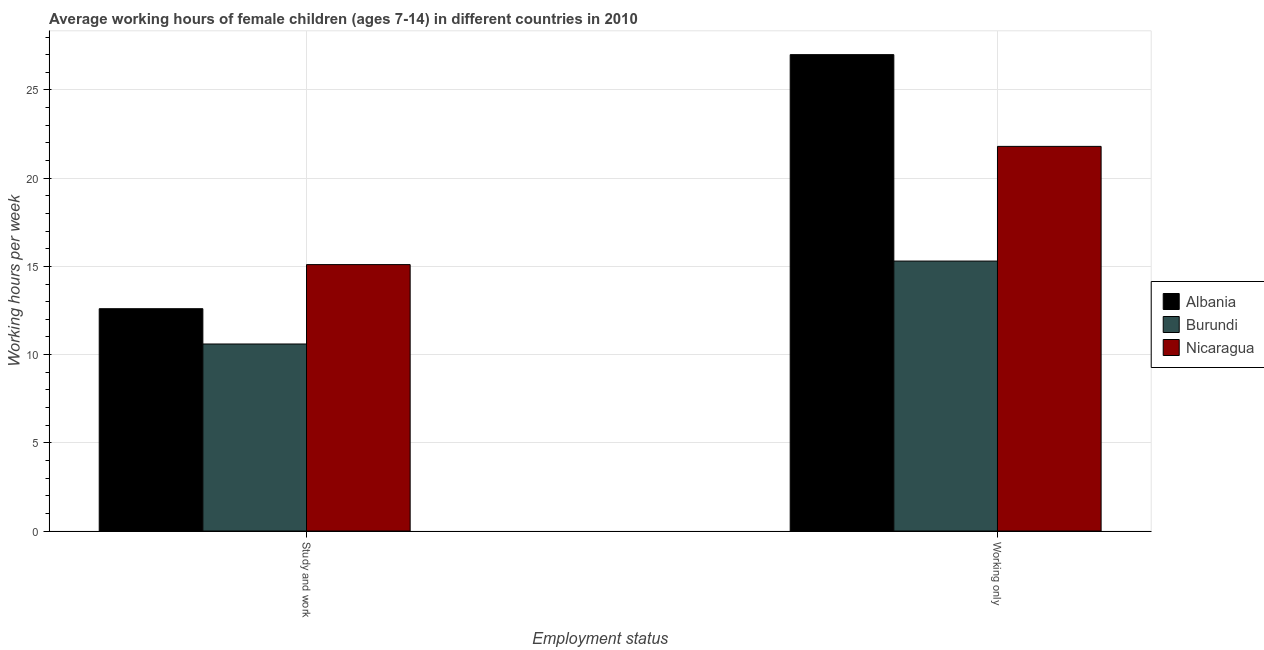Are the number of bars on each tick of the X-axis equal?
Offer a very short reply. Yes. How many bars are there on the 2nd tick from the right?
Give a very brief answer. 3. What is the label of the 1st group of bars from the left?
Provide a succinct answer. Study and work. In which country was the average working hour of children involved in study and work maximum?
Provide a succinct answer. Nicaragua. In which country was the average working hour of children involved in study and work minimum?
Offer a very short reply. Burundi. What is the total average working hour of children involved in study and work in the graph?
Offer a terse response. 38.3. What is the difference between the average working hour of children involved in only work in Burundi and the average working hour of children involved in study and work in Nicaragua?
Your response must be concise. 0.2. What is the average average working hour of children involved in study and work per country?
Provide a short and direct response. 12.77. What is the difference between the average working hour of children involved in study and work and average working hour of children involved in only work in Nicaragua?
Provide a short and direct response. -6.7. What is the ratio of the average working hour of children involved in only work in Burundi to that in Albania?
Provide a succinct answer. 0.57. Is the average working hour of children involved in study and work in Nicaragua less than that in Albania?
Your answer should be very brief. No. In how many countries, is the average working hour of children involved in study and work greater than the average average working hour of children involved in study and work taken over all countries?
Your answer should be compact. 1. What does the 1st bar from the left in Study and work represents?
Your answer should be compact. Albania. What does the 3rd bar from the right in Study and work represents?
Give a very brief answer. Albania. How many bars are there?
Provide a short and direct response. 6. Are all the bars in the graph horizontal?
Keep it short and to the point. No. Does the graph contain grids?
Ensure brevity in your answer.  Yes. How many legend labels are there?
Provide a succinct answer. 3. How are the legend labels stacked?
Provide a succinct answer. Vertical. What is the title of the graph?
Keep it short and to the point. Average working hours of female children (ages 7-14) in different countries in 2010. What is the label or title of the X-axis?
Keep it short and to the point. Employment status. What is the label or title of the Y-axis?
Keep it short and to the point. Working hours per week. What is the Working hours per week of Nicaragua in Study and work?
Your answer should be compact. 15.1. What is the Working hours per week in Albania in Working only?
Your response must be concise. 27. What is the Working hours per week in Burundi in Working only?
Offer a terse response. 15.3. What is the Working hours per week of Nicaragua in Working only?
Give a very brief answer. 21.8. Across all Employment status, what is the maximum Working hours per week in Albania?
Your answer should be very brief. 27. Across all Employment status, what is the maximum Working hours per week of Burundi?
Offer a terse response. 15.3. Across all Employment status, what is the maximum Working hours per week in Nicaragua?
Ensure brevity in your answer.  21.8. Across all Employment status, what is the minimum Working hours per week of Albania?
Give a very brief answer. 12.6. Across all Employment status, what is the minimum Working hours per week of Nicaragua?
Offer a very short reply. 15.1. What is the total Working hours per week in Albania in the graph?
Provide a succinct answer. 39.6. What is the total Working hours per week in Burundi in the graph?
Your answer should be very brief. 25.9. What is the total Working hours per week in Nicaragua in the graph?
Provide a short and direct response. 36.9. What is the difference between the Working hours per week in Albania in Study and work and that in Working only?
Your answer should be compact. -14.4. What is the difference between the Working hours per week of Burundi in Study and work and that in Working only?
Give a very brief answer. -4.7. What is the difference between the Working hours per week in Nicaragua in Study and work and that in Working only?
Your answer should be very brief. -6.7. What is the average Working hours per week in Albania per Employment status?
Make the answer very short. 19.8. What is the average Working hours per week of Burundi per Employment status?
Offer a very short reply. 12.95. What is the average Working hours per week of Nicaragua per Employment status?
Offer a terse response. 18.45. What is the difference between the Working hours per week of Albania and Working hours per week of Burundi in Study and work?
Your answer should be compact. 2. What is the difference between the Working hours per week in Albania and Working hours per week in Burundi in Working only?
Offer a terse response. 11.7. What is the ratio of the Working hours per week in Albania in Study and work to that in Working only?
Your answer should be compact. 0.47. What is the ratio of the Working hours per week in Burundi in Study and work to that in Working only?
Keep it short and to the point. 0.69. What is the ratio of the Working hours per week in Nicaragua in Study and work to that in Working only?
Make the answer very short. 0.69. What is the difference between the highest and the second highest Working hours per week of Albania?
Ensure brevity in your answer.  14.4. What is the difference between the highest and the second highest Working hours per week of Burundi?
Ensure brevity in your answer.  4.7. What is the difference between the highest and the second highest Working hours per week of Nicaragua?
Make the answer very short. 6.7. What is the difference between the highest and the lowest Working hours per week of Burundi?
Your answer should be compact. 4.7. What is the difference between the highest and the lowest Working hours per week of Nicaragua?
Provide a succinct answer. 6.7. 